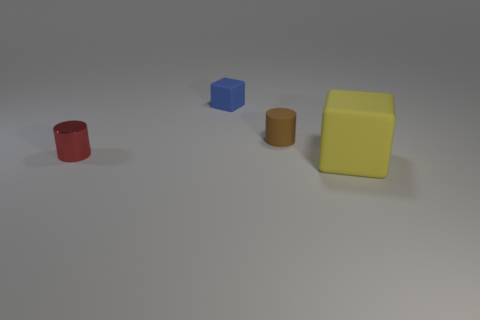What number of things are either yellow matte cubes or tiny red things?
Offer a terse response. 2. Is there any other thing that has the same size as the yellow matte thing?
Your answer should be very brief. No. The small matte thing to the right of the block behind the big yellow matte object is what shape?
Give a very brief answer. Cylinder. Are there fewer small metal objects than tiny blue metallic cubes?
Offer a very short reply. No. There is a object that is both on the left side of the brown matte cylinder and to the right of the red shiny object; what size is it?
Offer a very short reply. Small. Do the red shiny cylinder and the blue rubber thing have the same size?
Offer a terse response. Yes. What number of things are in front of the red metallic thing?
Your answer should be compact. 1. Are there more brown rubber cylinders than large cyan matte blocks?
Offer a very short reply. Yes. What shape is the thing that is on the left side of the matte cylinder and behind the small red cylinder?
Make the answer very short. Cube. Are there any big red metallic spheres?
Provide a short and direct response. No. 